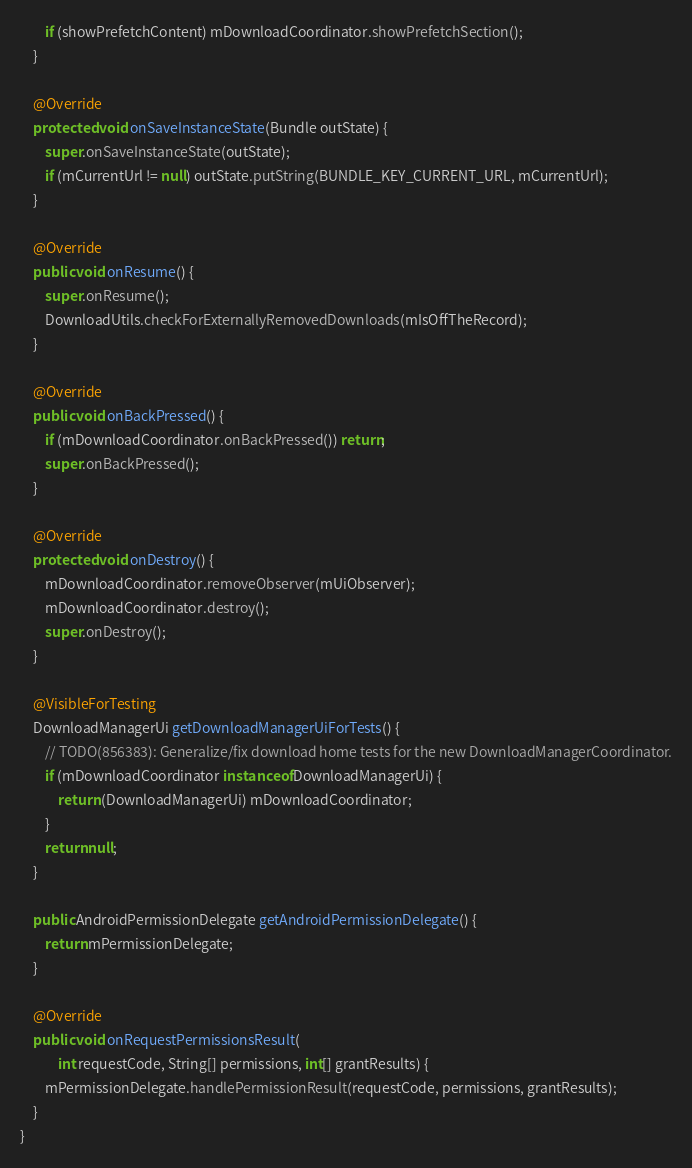Convert code to text. <code><loc_0><loc_0><loc_500><loc_500><_Java_>        if (showPrefetchContent) mDownloadCoordinator.showPrefetchSection();
    }

    @Override
    protected void onSaveInstanceState(Bundle outState) {
        super.onSaveInstanceState(outState);
        if (mCurrentUrl != null) outState.putString(BUNDLE_KEY_CURRENT_URL, mCurrentUrl);
    }

    @Override
    public void onResume() {
        super.onResume();
        DownloadUtils.checkForExternallyRemovedDownloads(mIsOffTheRecord);
    }

    @Override
    public void onBackPressed() {
        if (mDownloadCoordinator.onBackPressed()) return;
        super.onBackPressed();
    }

    @Override
    protected void onDestroy() {
        mDownloadCoordinator.removeObserver(mUiObserver);
        mDownloadCoordinator.destroy();
        super.onDestroy();
    }

    @VisibleForTesting
    DownloadManagerUi getDownloadManagerUiForTests() {
        // TODO(856383): Generalize/fix download home tests for the new DownloadManagerCoordinator.
        if (mDownloadCoordinator instanceof DownloadManagerUi) {
            return (DownloadManagerUi) mDownloadCoordinator;
        }
        return null;
    }

    public AndroidPermissionDelegate getAndroidPermissionDelegate() {
        return mPermissionDelegate;
    }

    @Override
    public void onRequestPermissionsResult(
            int requestCode, String[] permissions, int[] grantResults) {
        mPermissionDelegate.handlePermissionResult(requestCode, permissions, grantResults);
    }
}
</code> 